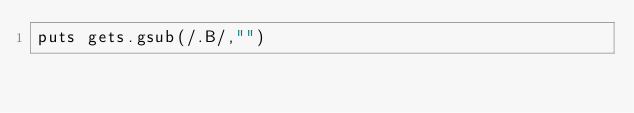<code> <loc_0><loc_0><loc_500><loc_500><_Ruby_>puts gets.gsub(/.B/,"")
</code> 